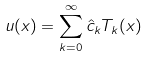Convert formula to latex. <formula><loc_0><loc_0><loc_500><loc_500>u ( x ) = \sum _ { k = 0 } ^ { \infty } \hat { c } _ { k } T _ { k } ( x )</formula> 